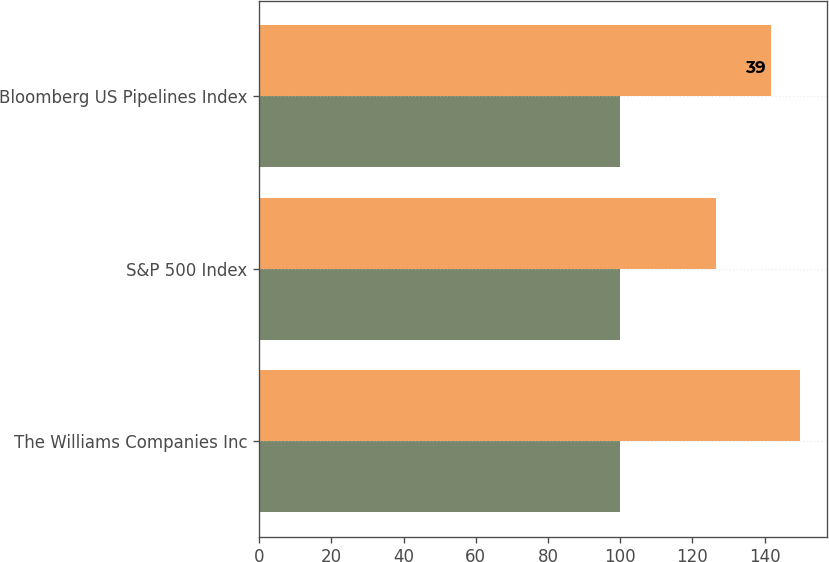<chart> <loc_0><loc_0><loc_500><loc_500><stacked_bar_chart><ecel><fcel>The Williams Companies Inc<fcel>S&P 500 Index<fcel>Bloomberg US Pipelines Index<nl><fcel>nan<fcel>100<fcel>100<fcel>100<nl><fcel>39<fcel>149.8<fcel>126.5<fcel>141.7<nl></chart> 